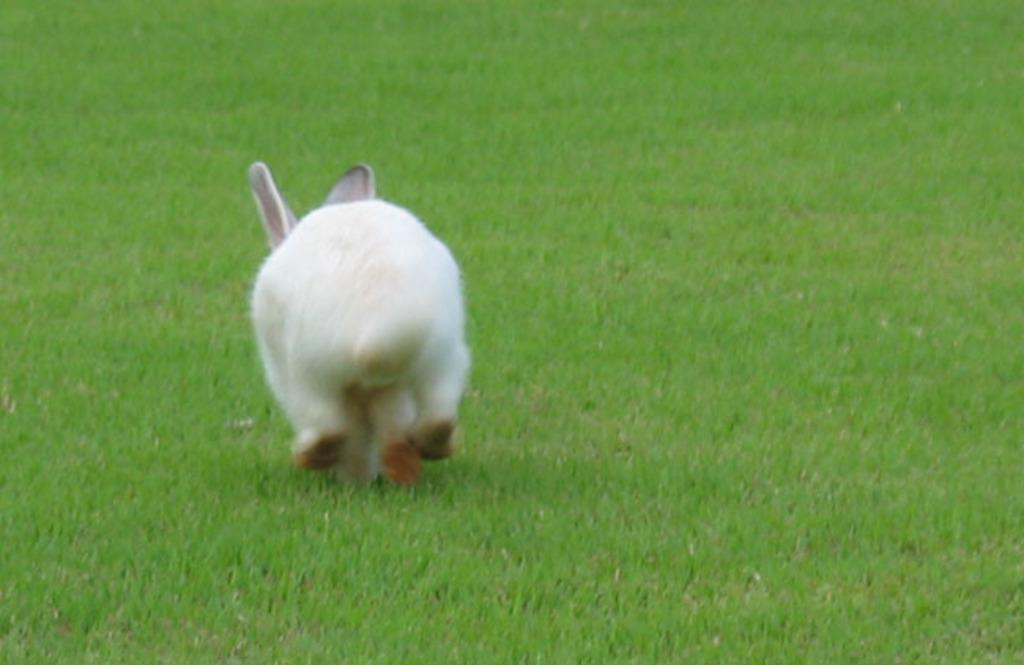What animal is present in the picture? There is a white rabbit in the picture. What type of vegetation can be seen in the background of the picture? There is grass visible in the background of the picture. Are there any fairies helping the carpenter make cheese in the image? There are no fairies, carpenters, or cheese present in the image; it only features a white rabbit and grass in the background. 